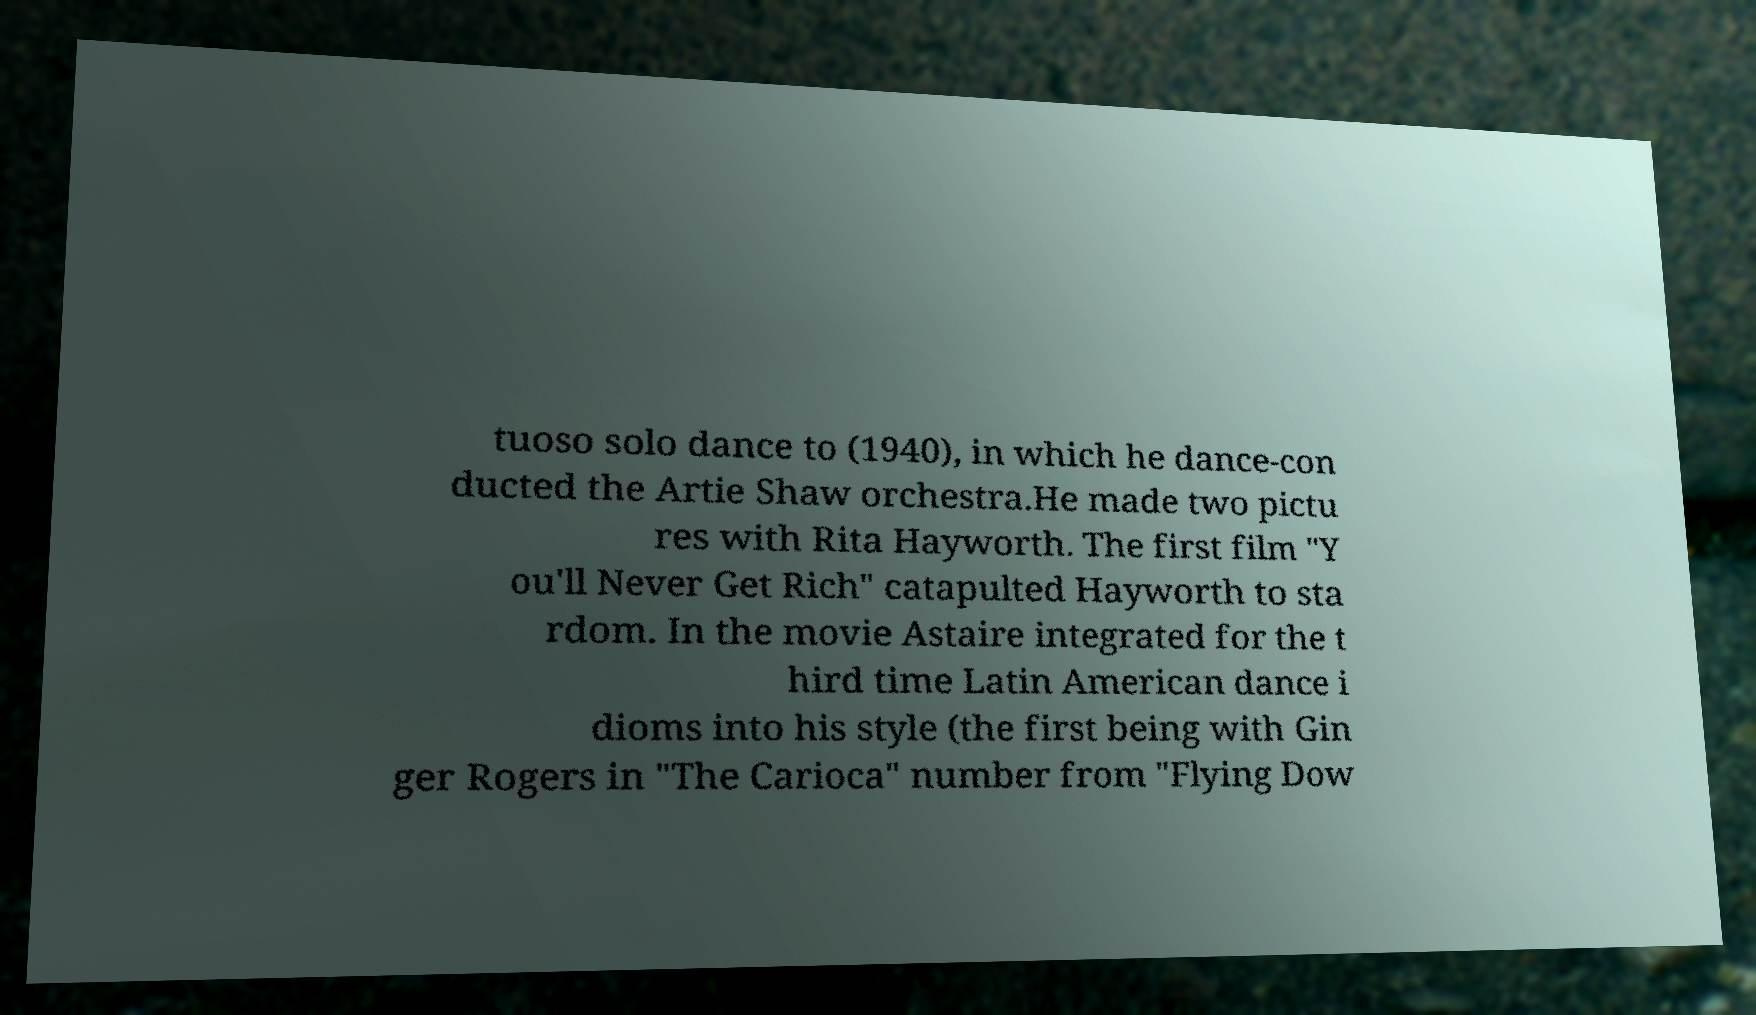Could you assist in decoding the text presented in this image and type it out clearly? tuoso solo dance to (1940), in which he dance-con ducted the Artie Shaw orchestra.He made two pictu res with Rita Hayworth. The first film "Y ou'll Never Get Rich" catapulted Hayworth to sta rdom. In the movie Astaire integrated for the t hird time Latin American dance i dioms into his style (the first being with Gin ger Rogers in "The Carioca" number from "Flying Dow 